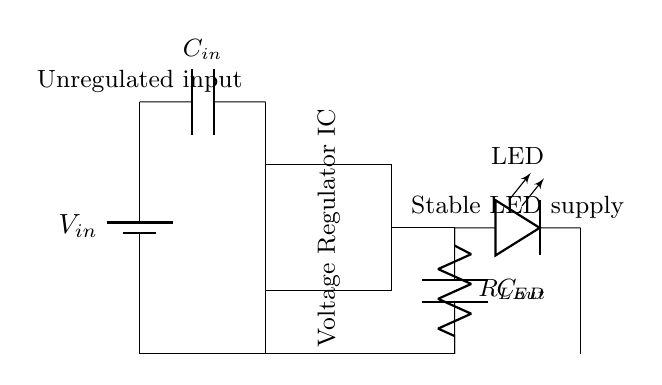What is the type of the power supply in this circuit? The power supply is identified as a battery, as indicated by the symbol that represents a voltage source.
Answer: Battery What does the voltage regulator IC do? The voltage regulator IC stabilizes the voltage output, ensuring that the LED receives a consistent voltage regardless of input fluctuations.
Answer: Stabilizes voltage What are the components connected to the output of the voltage regulator? The output of the voltage regulator connects to a resistor labeled R_LEDS and an LED, which draws current from the regulated voltage.
Answer: Resistor and LED How many capacitors are present in this circuit? There are two capacitors connected in the circuit: one at the input and one at the output.
Answer: Two Why is C_out important in this circuit? The output capacitor C_out helps filter the voltage, smoothing out any fluctuations and ensuring the LED receives stable power, which is critical for its operation.
Answer: Filters voltage What does R_LED represent in the circuit? R_LED is a resistor that limits the current, protecting the LED from receiving too much current which could damage it.
Answer: Current limiter What is the function of C_in in this circuit? C_in acts as a filter capacitor that helps smooth out the voltage from the input power supply before it enters the voltage regulator, improving stability and performance.
Answer: Smooths voltage 